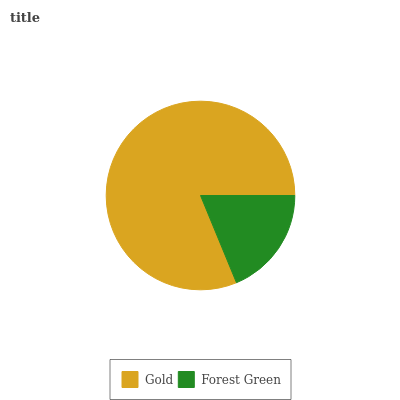Is Forest Green the minimum?
Answer yes or no. Yes. Is Gold the maximum?
Answer yes or no. Yes. Is Forest Green the maximum?
Answer yes or no. No. Is Gold greater than Forest Green?
Answer yes or no. Yes. Is Forest Green less than Gold?
Answer yes or no. Yes. Is Forest Green greater than Gold?
Answer yes or no. No. Is Gold less than Forest Green?
Answer yes or no. No. Is Gold the high median?
Answer yes or no. Yes. Is Forest Green the low median?
Answer yes or no. Yes. Is Forest Green the high median?
Answer yes or no. No. Is Gold the low median?
Answer yes or no. No. 